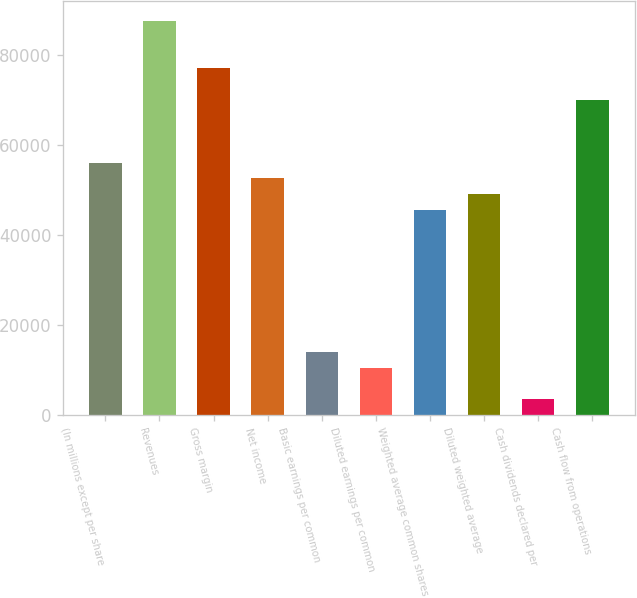Convert chart. <chart><loc_0><loc_0><loc_500><loc_500><bar_chart><fcel>(In millions except per share<fcel>Revenues<fcel>Gross margin<fcel>Net income<fcel>Basic earnings per common<fcel>Diluted earnings per common<fcel>Weighted average common shares<fcel>Diluted weighted average<fcel>Cash dividends declared per<fcel>Cash flow from operations<nl><fcel>56051<fcel>87579.6<fcel>77070<fcel>52547.8<fcel>14013<fcel>10509.8<fcel>45541.5<fcel>49044.7<fcel>3503.47<fcel>70063.7<nl></chart> 